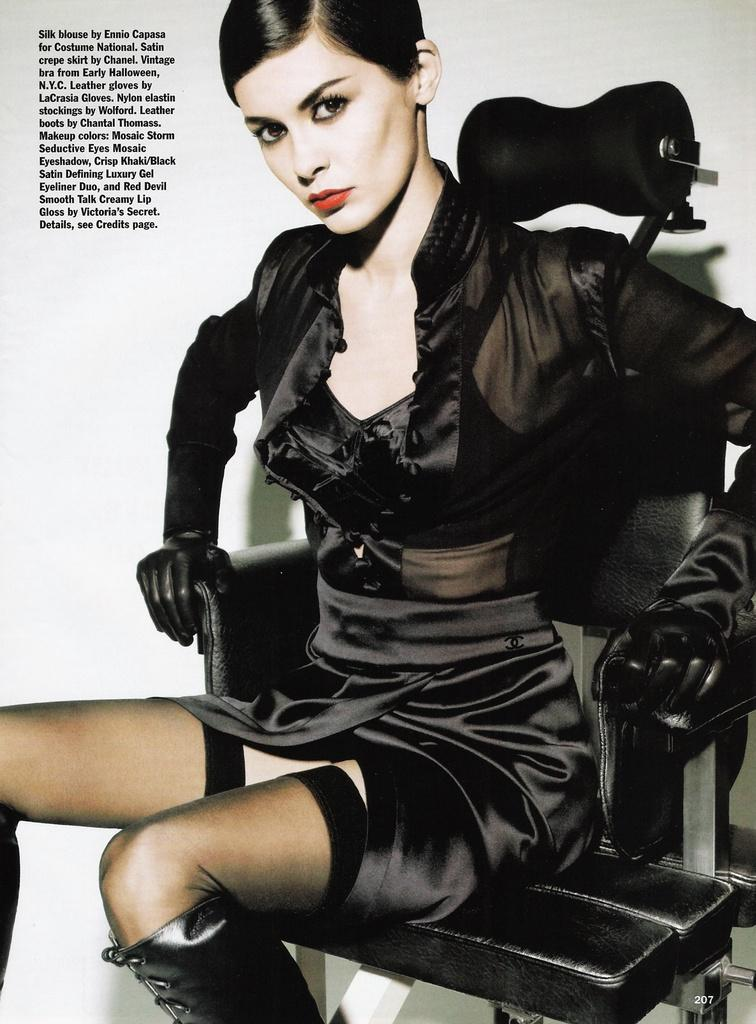What is the person in the image doing? The person is sitting on a chair. What is the person wearing? The person is wearing a black dress. Can you see a crack in the person's dress in the image? There is no mention of a crack in the person's dress in the provided facts, and therefore it cannot be determined from the image. 